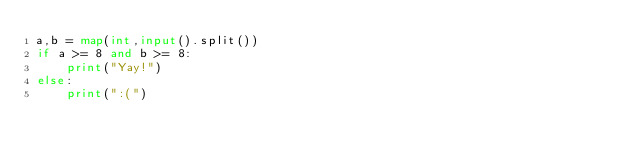<code> <loc_0><loc_0><loc_500><loc_500><_Python_>a,b = map(int,input().split())
if a >= 8 and b >= 8:
    print("Yay!")
else:
    print(":(")</code> 